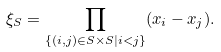Convert formula to latex. <formula><loc_0><loc_0><loc_500><loc_500>\xi _ { S } = \prod _ { \{ ( i , j ) \in S \times S | i < j \} } ( x _ { i } - x _ { j } ) .</formula> 